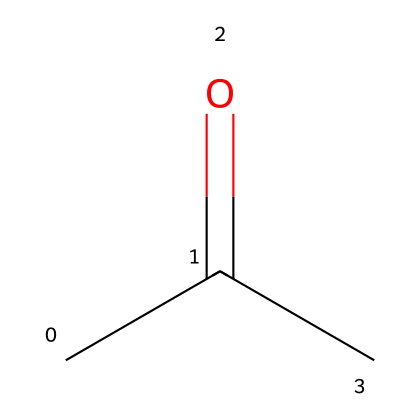What is the name of the chemical represented by this structure? The given SMILES representation corresponds to propanone, which is commonly known as acetone. This is identified from the structure where the carbonyl group (C=O) is located at the second carbon in a three-carbon chain.
Answer: propanone How many carbon atoms are in propanone? The SMILES representation shows three total carbon atoms connected in a chain with a carbonyl group. Counting the 'C' characters in the representation, we see three 'C's, confirming the total number.
Answer: 3 What type of functional group is present in propanone? In the structure, the C=O bond indicates the presence of a carbonyl group (C=O). Since this carbonyl is located between two carbon atoms, it classifies the compound as a ketone.
Answer: carbonyl What is the total number of hydrogen atoms in propanone? In the structure, each carbon atom can bond to hydrogen atoms to satisfy the tetravalency. Given the three carbons and one carbonyl oxygen, we find there are six hydrogen atoms (C3H6O).
Answer: 6 Which part of propanone determines its classification as a ketone? The carbonyl group (C=O) is key in classifying propanone as a ketone. It is flanked by two carbon atoms, which is a definitive characteristic of ketones compared to aldehydes.
Answer: carbonyl group What are the general properties of ketones, like propanone? Ketones, including propanone, are known to be polar due to the carbonyl group, and typically have a pleasant odor. They are also relatively volatile and soluble in water and organic solvents.
Answer: polar, volatile Why is propanone used in some self-tanning products? Propanone is often used for its solvent properties, helping to dissolve and evenly distribute the tanning agents in self-tanning products. Its quick evaporation rate aids in rapid drying.
Answer: solvent properties 